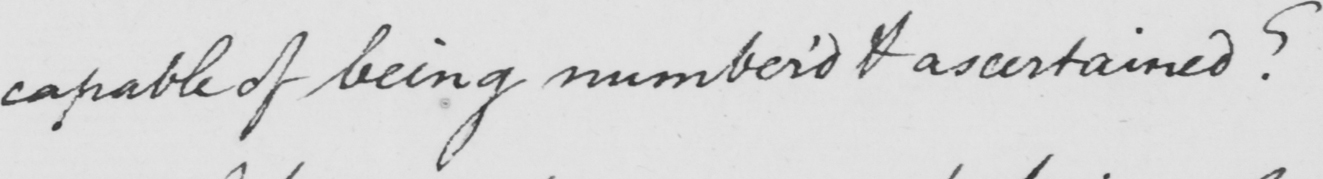What text is written in this handwritten line? capable of being number ' d & ascertained ? 